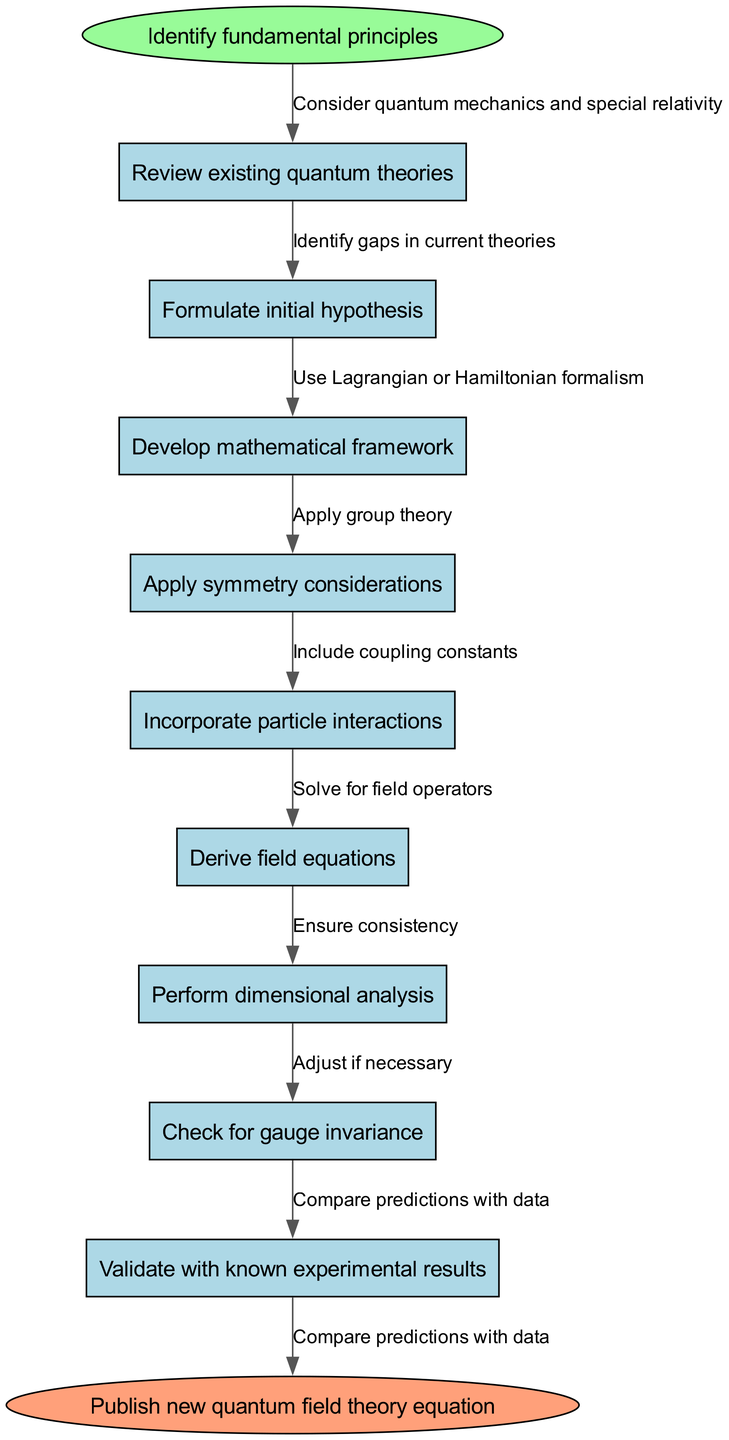What is the first node in the flow chart? The first node is clearly labeled as "Identify fundamental principles," which is the starting point of the diagram.
Answer: Identify fundamental principles How many nodes are present in the diagram? Counting the start node, each intermediate node, and the end node gives a total of 10 nodes in the entire flow chart.
Answer: 10 What is the last action before publishing the new quantum field theory equation? The last action performed before reaching the end node "Publish new quantum field theory equation" is "Compare predictions with data," which is the final step in the process.
Answer: Compare predictions with data Which step involves mathematical formalism? The step labeled "Develop mathematical framework" indicates the utilization of mathematical formalism in the derivation process of the quantum field theory equation.
Answer: Develop mathematical framework What is the relationship between "Incorporate particle interactions" and "Derive field equations"? "Incorporate particle interactions" must be completed first to provide the necessary context before progressing to "Derive field equations," indicating a direct flow in the process.
Answer: Incorporate particle interactions → Derive field equations What principle is applied during the "Apply symmetry considerations" node? The "Apply symmetry considerations" node suggests the use of "group theory" to explore and utilize symmetries in the derivation process, which is essential in field theories.
Answer: Group theory How does one ensure the consistency of dimensional analysis? To ensure consistency of dimensional analysis, the step "Perform dimensional analysis" is necessary, as it checks that all terms in equations have appropriate dimensions.
Answer: Perform dimensional analysis What is the purpose of checking for gauge invariance? Checking for gauge invariance helps confirm that the equations derived comply with gauge symmetries required for consistency in quantum field theories, ensuring the physical validity of the model.
Answer: Confirm consistency with gauge symmetries What connecting edge is associated with "Review existing quantum theories"? The edge labeled "Identify gaps in current theories" is connected to the node "Review existing quantum theories," indicating that reviewing is informed by the existing gaps.
Answer: Identify gaps in current theories 